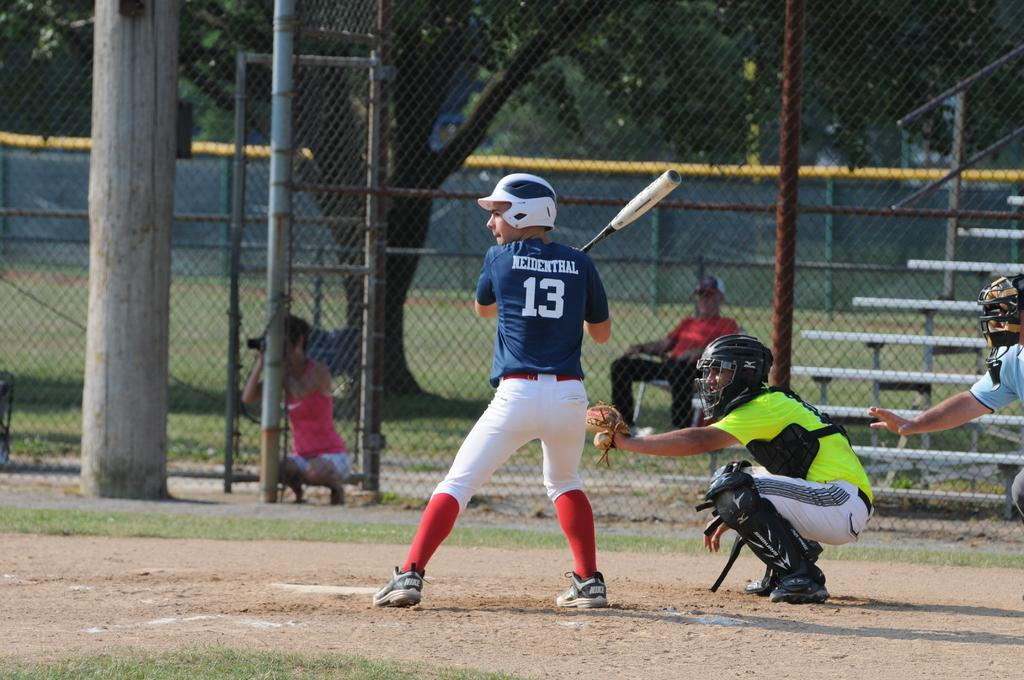Provide a one-sentence caption for the provided image. A boy at bat with 13 on his jersey in a baseball game. 